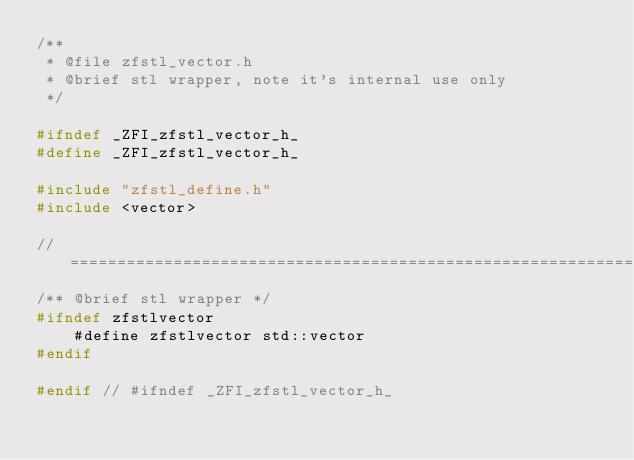Convert code to text. <code><loc_0><loc_0><loc_500><loc_500><_C_>/**
 * @file zfstl_vector.h
 * @brief stl wrapper, note it's internal use only
 */

#ifndef _ZFI_zfstl_vector_h_
#define _ZFI_zfstl_vector_h_

#include "zfstl_define.h"
#include <vector>

// ============================================================
/** @brief stl wrapper */
#ifndef zfstlvector
    #define zfstlvector std::vector
#endif

#endif // #ifndef _ZFI_zfstl_vector_h_

</code> 